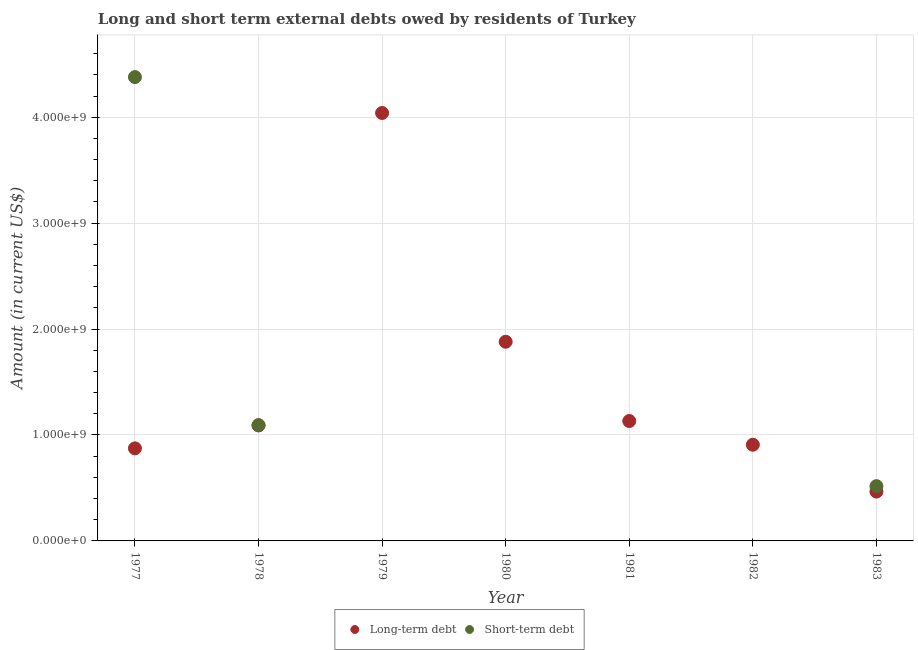How many different coloured dotlines are there?
Your answer should be compact. 2. Is the number of dotlines equal to the number of legend labels?
Give a very brief answer. No. What is the long-term debts owed by residents in 1977?
Provide a succinct answer. 8.74e+08. Across all years, what is the maximum short-term debts owed by residents?
Your answer should be compact. 4.38e+09. Across all years, what is the minimum short-term debts owed by residents?
Provide a short and direct response. 0. In which year was the long-term debts owed by residents maximum?
Your answer should be compact. 1979. What is the total long-term debts owed by residents in the graph?
Provide a succinct answer. 1.04e+1. What is the difference between the short-term debts owed by residents in 1978 and that in 1983?
Ensure brevity in your answer.  5.76e+08. What is the difference between the short-term debts owed by residents in 1980 and the long-term debts owed by residents in 1977?
Your response must be concise. -8.74e+08. What is the average long-term debts owed by residents per year?
Your answer should be very brief. 1.48e+09. In the year 1983, what is the difference between the short-term debts owed by residents and long-term debts owed by residents?
Provide a short and direct response. 5.09e+07. What is the ratio of the long-term debts owed by residents in 1980 to that in 1983?
Your answer should be compact. 4.03. What is the difference between the highest and the second highest long-term debts owed by residents?
Keep it short and to the point. 2.16e+09. What is the difference between the highest and the lowest short-term debts owed by residents?
Ensure brevity in your answer.  4.38e+09. Is the sum of the long-term debts owed by residents in 1977 and 1980 greater than the maximum short-term debts owed by residents across all years?
Provide a succinct answer. No. Is the long-term debts owed by residents strictly less than the short-term debts owed by residents over the years?
Your answer should be very brief. No. How many years are there in the graph?
Offer a very short reply. 7. What is the difference between two consecutive major ticks on the Y-axis?
Your answer should be very brief. 1.00e+09. How many legend labels are there?
Provide a succinct answer. 2. How are the legend labels stacked?
Ensure brevity in your answer.  Horizontal. What is the title of the graph?
Your answer should be compact. Long and short term external debts owed by residents of Turkey. Does "Underweight" appear as one of the legend labels in the graph?
Your answer should be compact. No. What is the label or title of the X-axis?
Provide a succinct answer. Year. What is the label or title of the Y-axis?
Give a very brief answer. Amount (in current US$). What is the Amount (in current US$) of Long-term debt in 1977?
Give a very brief answer. 8.74e+08. What is the Amount (in current US$) of Short-term debt in 1977?
Keep it short and to the point. 4.38e+09. What is the Amount (in current US$) in Long-term debt in 1978?
Your answer should be compact. 1.09e+09. What is the Amount (in current US$) in Short-term debt in 1978?
Keep it short and to the point. 1.09e+09. What is the Amount (in current US$) in Long-term debt in 1979?
Provide a short and direct response. 4.04e+09. What is the Amount (in current US$) of Long-term debt in 1980?
Offer a terse response. 1.88e+09. What is the Amount (in current US$) in Short-term debt in 1980?
Provide a short and direct response. 0. What is the Amount (in current US$) in Long-term debt in 1981?
Your response must be concise. 1.13e+09. What is the Amount (in current US$) in Long-term debt in 1982?
Provide a succinct answer. 9.08e+08. What is the Amount (in current US$) in Short-term debt in 1982?
Your answer should be compact. 0. What is the Amount (in current US$) of Long-term debt in 1983?
Ensure brevity in your answer.  4.66e+08. What is the Amount (in current US$) in Short-term debt in 1983?
Keep it short and to the point. 5.17e+08. Across all years, what is the maximum Amount (in current US$) of Long-term debt?
Make the answer very short. 4.04e+09. Across all years, what is the maximum Amount (in current US$) of Short-term debt?
Offer a very short reply. 4.38e+09. Across all years, what is the minimum Amount (in current US$) of Long-term debt?
Make the answer very short. 4.66e+08. Across all years, what is the minimum Amount (in current US$) of Short-term debt?
Keep it short and to the point. 0. What is the total Amount (in current US$) of Long-term debt in the graph?
Your response must be concise. 1.04e+1. What is the total Amount (in current US$) of Short-term debt in the graph?
Provide a short and direct response. 5.99e+09. What is the difference between the Amount (in current US$) of Long-term debt in 1977 and that in 1978?
Offer a very short reply. -2.17e+08. What is the difference between the Amount (in current US$) of Short-term debt in 1977 and that in 1978?
Keep it short and to the point. 3.29e+09. What is the difference between the Amount (in current US$) in Long-term debt in 1977 and that in 1979?
Provide a succinct answer. -3.17e+09. What is the difference between the Amount (in current US$) in Long-term debt in 1977 and that in 1980?
Keep it short and to the point. -1.01e+09. What is the difference between the Amount (in current US$) of Long-term debt in 1977 and that in 1981?
Your response must be concise. -2.58e+08. What is the difference between the Amount (in current US$) of Long-term debt in 1977 and that in 1982?
Provide a short and direct response. -3.42e+07. What is the difference between the Amount (in current US$) in Long-term debt in 1977 and that in 1983?
Give a very brief answer. 4.08e+08. What is the difference between the Amount (in current US$) of Short-term debt in 1977 and that in 1983?
Give a very brief answer. 3.86e+09. What is the difference between the Amount (in current US$) in Long-term debt in 1978 and that in 1979?
Offer a terse response. -2.95e+09. What is the difference between the Amount (in current US$) of Long-term debt in 1978 and that in 1980?
Your answer should be compact. -7.90e+08. What is the difference between the Amount (in current US$) of Long-term debt in 1978 and that in 1981?
Provide a short and direct response. -4.15e+07. What is the difference between the Amount (in current US$) in Long-term debt in 1978 and that in 1982?
Ensure brevity in your answer.  1.82e+08. What is the difference between the Amount (in current US$) of Long-term debt in 1978 and that in 1983?
Ensure brevity in your answer.  6.24e+08. What is the difference between the Amount (in current US$) in Short-term debt in 1978 and that in 1983?
Offer a very short reply. 5.76e+08. What is the difference between the Amount (in current US$) in Long-term debt in 1979 and that in 1980?
Ensure brevity in your answer.  2.16e+09. What is the difference between the Amount (in current US$) of Long-term debt in 1979 and that in 1981?
Make the answer very short. 2.91e+09. What is the difference between the Amount (in current US$) in Long-term debt in 1979 and that in 1982?
Make the answer very short. 3.13e+09. What is the difference between the Amount (in current US$) in Long-term debt in 1979 and that in 1983?
Provide a succinct answer. 3.57e+09. What is the difference between the Amount (in current US$) of Long-term debt in 1980 and that in 1981?
Your response must be concise. 7.48e+08. What is the difference between the Amount (in current US$) of Long-term debt in 1980 and that in 1982?
Keep it short and to the point. 9.72e+08. What is the difference between the Amount (in current US$) in Long-term debt in 1980 and that in 1983?
Keep it short and to the point. 1.41e+09. What is the difference between the Amount (in current US$) of Long-term debt in 1981 and that in 1982?
Ensure brevity in your answer.  2.24e+08. What is the difference between the Amount (in current US$) of Long-term debt in 1981 and that in 1983?
Provide a succinct answer. 6.66e+08. What is the difference between the Amount (in current US$) of Long-term debt in 1982 and that in 1983?
Offer a terse response. 4.42e+08. What is the difference between the Amount (in current US$) in Long-term debt in 1977 and the Amount (in current US$) in Short-term debt in 1978?
Offer a terse response. -2.19e+08. What is the difference between the Amount (in current US$) in Long-term debt in 1977 and the Amount (in current US$) in Short-term debt in 1983?
Offer a very short reply. 3.57e+08. What is the difference between the Amount (in current US$) of Long-term debt in 1978 and the Amount (in current US$) of Short-term debt in 1983?
Your answer should be very brief. 5.74e+08. What is the difference between the Amount (in current US$) in Long-term debt in 1979 and the Amount (in current US$) in Short-term debt in 1983?
Offer a terse response. 3.52e+09. What is the difference between the Amount (in current US$) of Long-term debt in 1980 and the Amount (in current US$) of Short-term debt in 1983?
Your response must be concise. 1.36e+09. What is the difference between the Amount (in current US$) of Long-term debt in 1981 and the Amount (in current US$) of Short-term debt in 1983?
Offer a very short reply. 6.15e+08. What is the difference between the Amount (in current US$) of Long-term debt in 1982 and the Amount (in current US$) of Short-term debt in 1983?
Ensure brevity in your answer.  3.91e+08. What is the average Amount (in current US$) in Long-term debt per year?
Offer a very short reply. 1.48e+09. What is the average Amount (in current US$) in Short-term debt per year?
Ensure brevity in your answer.  8.56e+08. In the year 1977, what is the difference between the Amount (in current US$) of Long-term debt and Amount (in current US$) of Short-term debt?
Your answer should be compact. -3.51e+09. In the year 1978, what is the difference between the Amount (in current US$) in Long-term debt and Amount (in current US$) in Short-term debt?
Offer a terse response. -2.44e+06. In the year 1983, what is the difference between the Amount (in current US$) of Long-term debt and Amount (in current US$) of Short-term debt?
Give a very brief answer. -5.09e+07. What is the ratio of the Amount (in current US$) of Long-term debt in 1977 to that in 1978?
Ensure brevity in your answer.  0.8. What is the ratio of the Amount (in current US$) of Short-term debt in 1977 to that in 1978?
Ensure brevity in your answer.  4.01. What is the ratio of the Amount (in current US$) in Long-term debt in 1977 to that in 1979?
Keep it short and to the point. 0.22. What is the ratio of the Amount (in current US$) in Long-term debt in 1977 to that in 1980?
Offer a very short reply. 0.46. What is the ratio of the Amount (in current US$) of Long-term debt in 1977 to that in 1981?
Your answer should be compact. 0.77. What is the ratio of the Amount (in current US$) in Long-term debt in 1977 to that in 1982?
Your answer should be very brief. 0.96. What is the ratio of the Amount (in current US$) of Long-term debt in 1977 to that in 1983?
Provide a succinct answer. 1.88. What is the ratio of the Amount (in current US$) in Short-term debt in 1977 to that in 1983?
Offer a very short reply. 8.47. What is the ratio of the Amount (in current US$) of Long-term debt in 1978 to that in 1979?
Offer a terse response. 0.27. What is the ratio of the Amount (in current US$) of Long-term debt in 1978 to that in 1980?
Your answer should be compact. 0.58. What is the ratio of the Amount (in current US$) in Long-term debt in 1978 to that in 1981?
Ensure brevity in your answer.  0.96. What is the ratio of the Amount (in current US$) in Long-term debt in 1978 to that in 1982?
Offer a very short reply. 1.2. What is the ratio of the Amount (in current US$) in Long-term debt in 1978 to that in 1983?
Offer a terse response. 2.34. What is the ratio of the Amount (in current US$) in Short-term debt in 1978 to that in 1983?
Ensure brevity in your answer.  2.11. What is the ratio of the Amount (in current US$) in Long-term debt in 1979 to that in 1980?
Your answer should be very brief. 2.15. What is the ratio of the Amount (in current US$) in Long-term debt in 1979 to that in 1981?
Provide a succinct answer. 3.57. What is the ratio of the Amount (in current US$) in Long-term debt in 1979 to that in 1982?
Ensure brevity in your answer.  4.45. What is the ratio of the Amount (in current US$) of Long-term debt in 1979 to that in 1983?
Your answer should be very brief. 8.67. What is the ratio of the Amount (in current US$) of Long-term debt in 1980 to that in 1981?
Provide a succinct answer. 1.66. What is the ratio of the Amount (in current US$) of Long-term debt in 1980 to that in 1982?
Your response must be concise. 2.07. What is the ratio of the Amount (in current US$) in Long-term debt in 1980 to that in 1983?
Your answer should be very brief. 4.03. What is the ratio of the Amount (in current US$) of Long-term debt in 1981 to that in 1982?
Your answer should be very brief. 1.25. What is the ratio of the Amount (in current US$) in Long-term debt in 1981 to that in 1983?
Offer a very short reply. 2.43. What is the ratio of the Amount (in current US$) of Long-term debt in 1982 to that in 1983?
Give a very brief answer. 1.95. What is the difference between the highest and the second highest Amount (in current US$) in Long-term debt?
Ensure brevity in your answer.  2.16e+09. What is the difference between the highest and the second highest Amount (in current US$) in Short-term debt?
Provide a short and direct response. 3.29e+09. What is the difference between the highest and the lowest Amount (in current US$) in Long-term debt?
Your answer should be compact. 3.57e+09. What is the difference between the highest and the lowest Amount (in current US$) of Short-term debt?
Your response must be concise. 4.38e+09. 